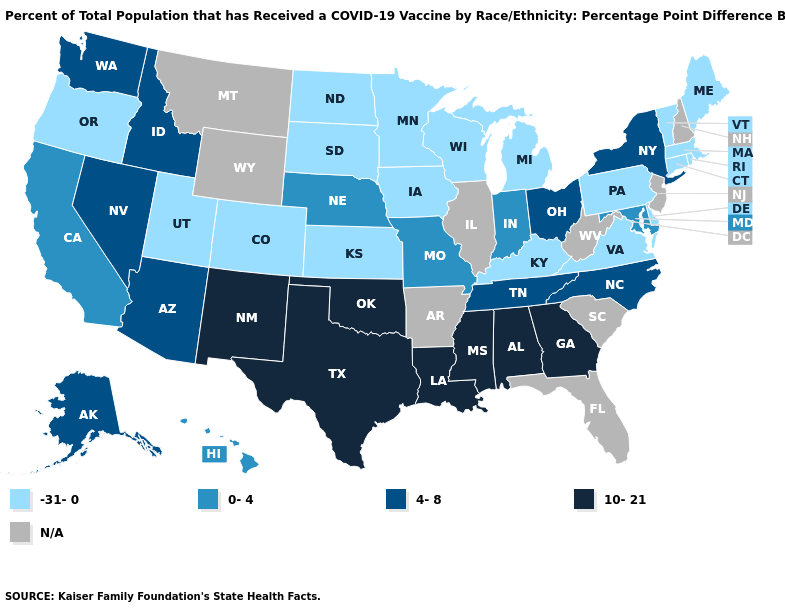Name the states that have a value in the range 4-8?
Keep it brief. Alaska, Arizona, Idaho, Nevada, New York, North Carolina, Ohio, Tennessee, Washington. How many symbols are there in the legend?
Quick response, please. 5. What is the value of Michigan?
Be succinct. -31-0. Does Colorado have the lowest value in the USA?
Write a very short answer. Yes. Among the states that border New Hampshire , which have the highest value?
Short answer required. Maine, Massachusetts, Vermont. How many symbols are there in the legend?
Concise answer only. 5. Name the states that have a value in the range N/A?
Concise answer only. Arkansas, Florida, Illinois, Montana, New Hampshire, New Jersey, South Carolina, West Virginia, Wyoming. Does Oregon have the highest value in the USA?
Short answer required. No. Name the states that have a value in the range -31-0?
Answer briefly. Colorado, Connecticut, Delaware, Iowa, Kansas, Kentucky, Maine, Massachusetts, Michigan, Minnesota, North Dakota, Oregon, Pennsylvania, Rhode Island, South Dakota, Utah, Vermont, Virginia, Wisconsin. What is the highest value in states that border California?
Concise answer only. 4-8. What is the lowest value in the USA?
Write a very short answer. -31-0. Which states hav the highest value in the South?
Keep it brief. Alabama, Georgia, Louisiana, Mississippi, Oklahoma, Texas. Name the states that have a value in the range N/A?
Short answer required. Arkansas, Florida, Illinois, Montana, New Hampshire, New Jersey, South Carolina, West Virginia, Wyoming. What is the lowest value in the USA?
Keep it brief. -31-0. 